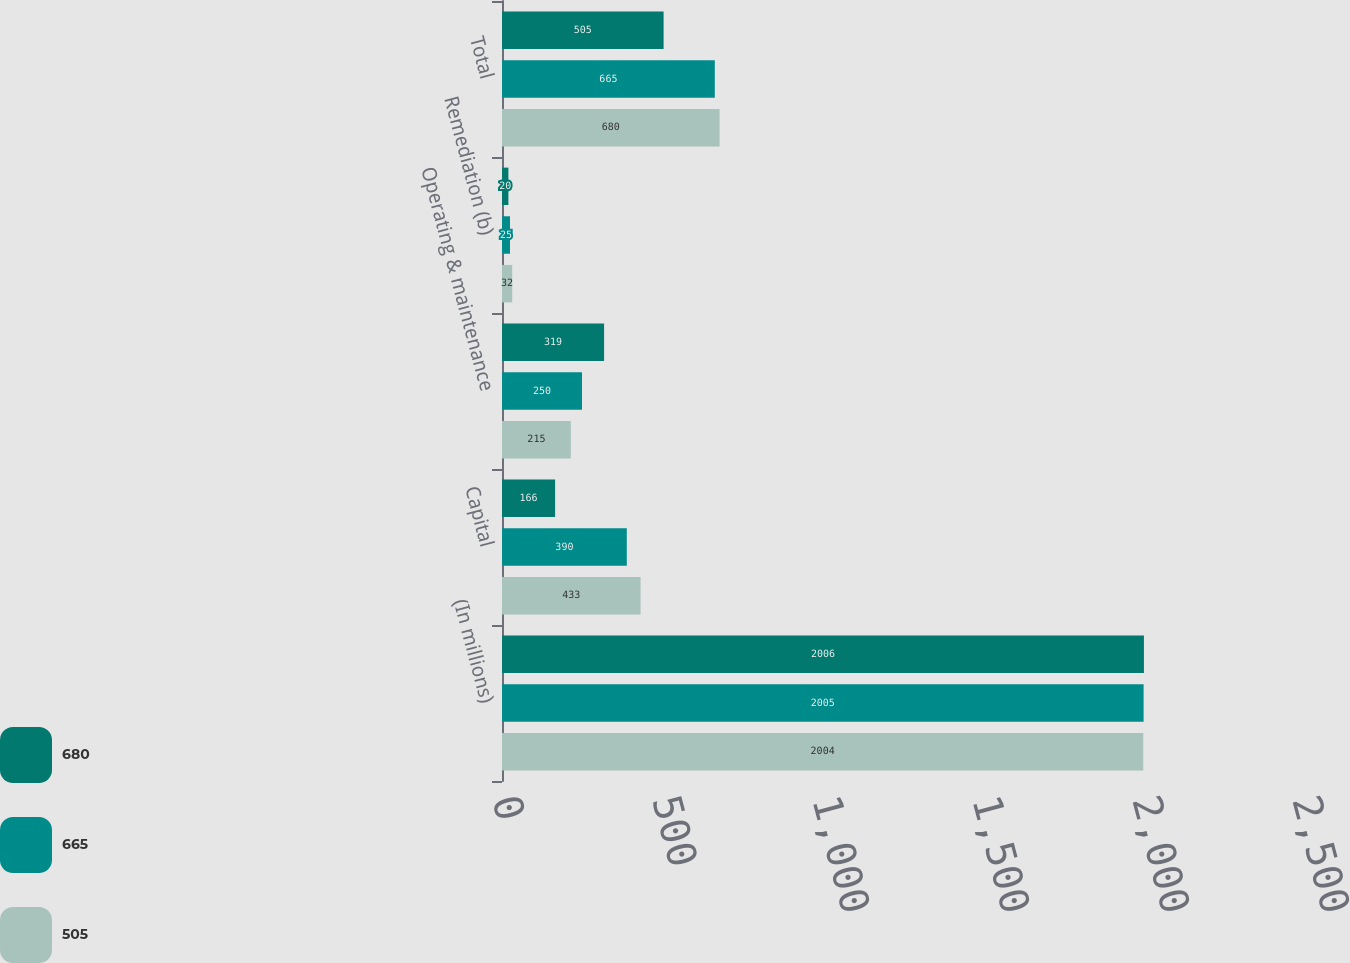Convert chart to OTSL. <chart><loc_0><loc_0><loc_500><loc_500><stacked_bar_chart><ecel><fcel>(In millions)<fcel>Capital<fcel>Operating & maintenance<fcel>Remediation (b)<fcel>Total<nl><fcel>680<fcel>2006<fcel>166<fcel>319<fcel>20<fcel>505<nl><fcel>665<fcel>2005<fcel>390<fcel>250<fcel>25<fcel>665<nl><fcel>505<fcel>2004<fcel>433<fcel>215<fcel>32<fcel>680<nl></chart> 